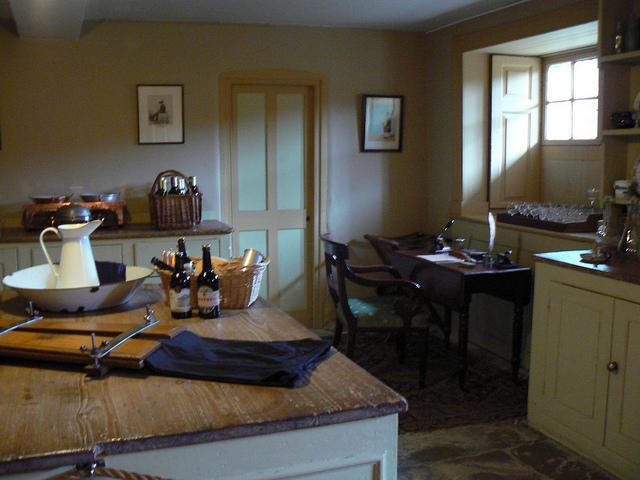How many pictures are hanging on the wall?

Choices:
A) six
B) four
C) two
D) one two 